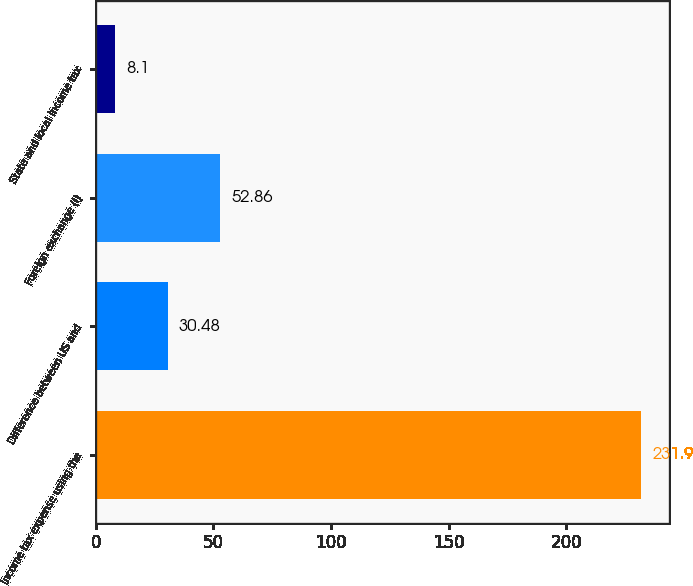Convert chart. <chart><loc_0><loc_0><loc_500><loc_500><bar_chart><fcel>Income tax expense using the<fcel>Difference between US and<fcel>Foreign exchange (i)<fcel>State and local income tax<nl><fcel>231.9<fcel>30.48<fcel>52.86<fcel>8.1<nl></chart> 